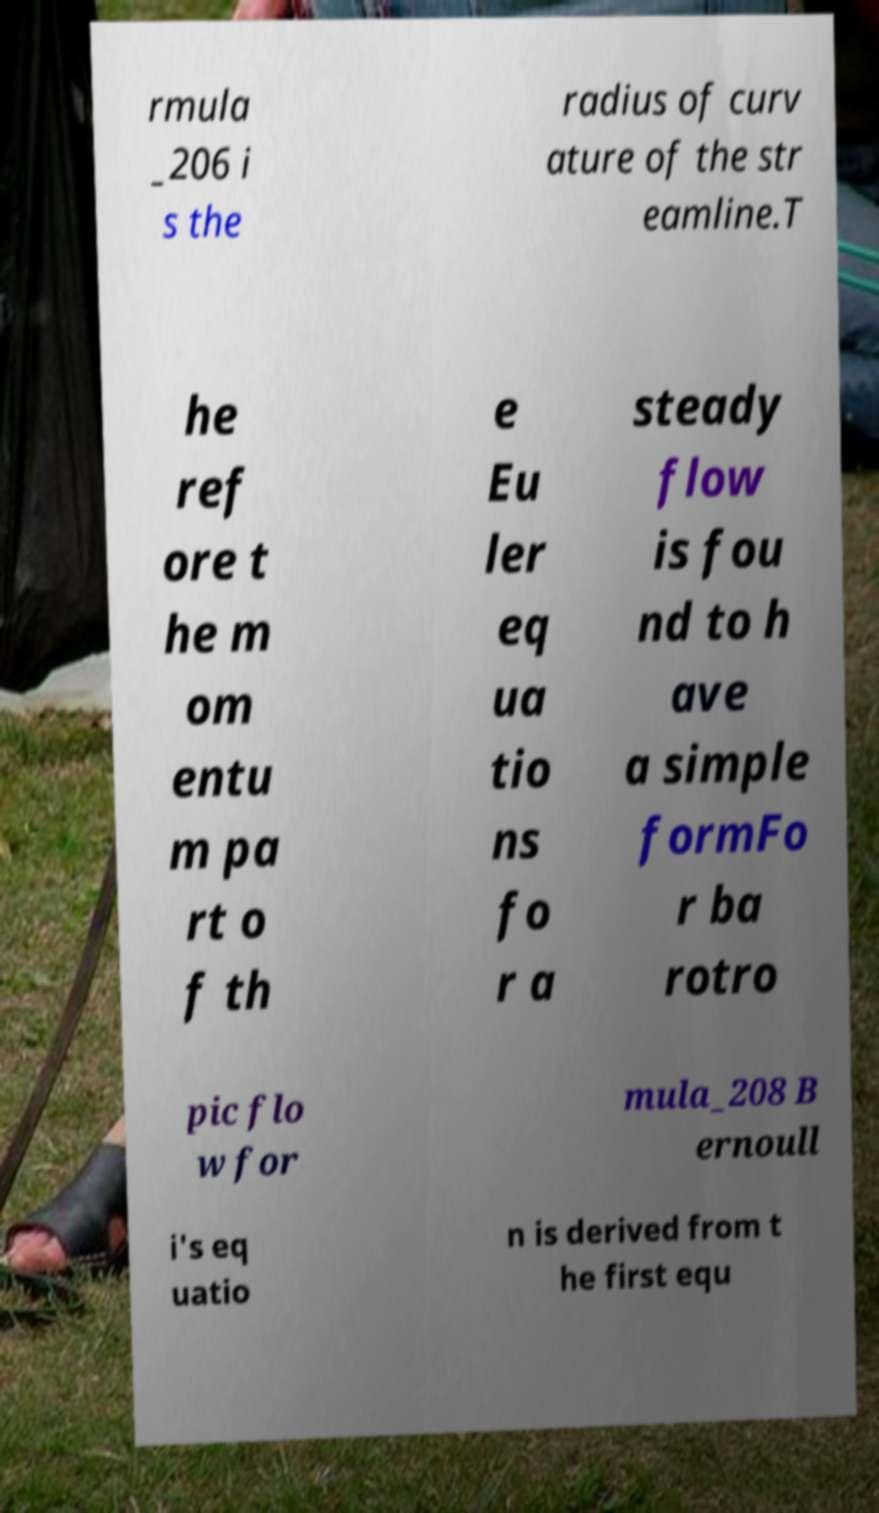Please identify and transcribe the text found in this image. rmula _206 i s the radius of curv ature of the str eamline.T he ref ore t he m om entu m pa rt o f th e Eu ler eq ua tio ns fo r a steady flow is fou nd to h ave a simple formFo r ba rotro pic flo w for mula_208 B ernoull i's eq uatio n is derived from t he first equ 